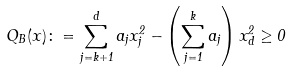Convert formula to latex. <formula><loc_0><loc_0><loc_500><loc_500>Q _ { B } ( x ) \colon = \sum _ { j = k + 1 } ^ { d } a _ { j } x _ { j } ^ { 2 } - \left ( \sum _ { j = 1 } ^ { k } a _ { j } \right ) x _ { d } ^ { 2 } \geq 0 \,</formula> 